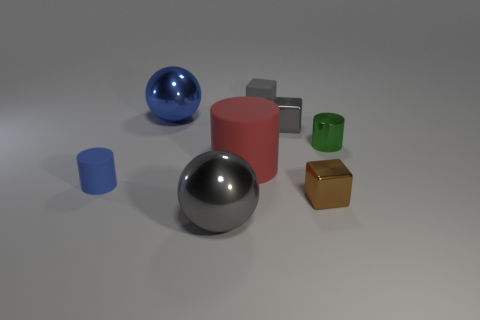What might be the relative sizes of these objects based on their appearance in the image? Based on visual assessment, the large silver sphere and the large blue sphere seem to be the biggest objects in the scene. The medium-sized red cylinder is slightly smaller in scale, whereas the small green cylinder, the small grey cube, and the small gold cube appear to be the smallest objects among them. If these objects had weights, which one do you think would be the heaviest and why? If we were to speculate about the weight of these objects based on their material appearance and size, the large silver sphere might be the heaviest if it's made of metal. Its size and reflective surface suggest a denser material. However, this is purely hypothetical as the actual material of the objects is not confirmed. 